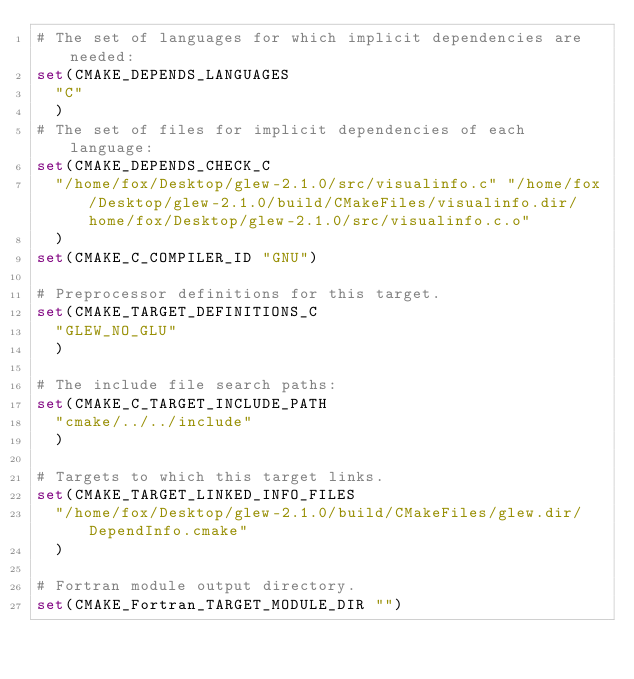Convert code to text. <code><loc_0><loc_0><loc_500><loc_500><_CMake_># The set of languages for which implicit dependencies are needed:
set(CMAKE_DEPENDS_LANGUAGES
  "C"
  )
# The set of files for implicit dependencies of each language:
set(CMAKE_DEPENDS_CHECK_C
  "/home/fox/Desktop/glew-2.1.0/src/visualinfo.c" "/home/fox/Desktop/glew-2.1.0/build/CMakeFiles/visualinfo.dir/home/fox/Desktop/glew-2.1.0/src/visualinfo.c.o"
  )
set(CMAKE_C_COMPILER_ID "GNU")

# Preprocessor definitions for this target.
set(CMAKE_TARGET_DEFINITIONS_C
  "GLEW_NO_GLU"
  )

# The include file search paths:
set(CMAKE_C_TARGET_INCLUDE_PATH
  "cmake/../../include"
  )

# Targets to which this target links.
set(CMAKE_TARGET_LINKED_INFO_FILES
  "/home/fox/Desktop/glew-2.1.0/build/CMakeFiles/glew.dir/DependInfo.cmake"
  )

# Fortran module output directory.
set(CMAKE_Fortran_TARGET_MODULE_DIR "")
</code> 